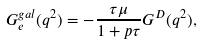Convert formula to latex. <formula><loc_0><loc_0><loc_500><loc_500>G ^ { g a l } _ { e } ( q ^ { 2 } ) = - \frac { \tau \mu } { 1 + p \tau } G ^ { D } ( q ^ { 2 } ) ,</formula> 